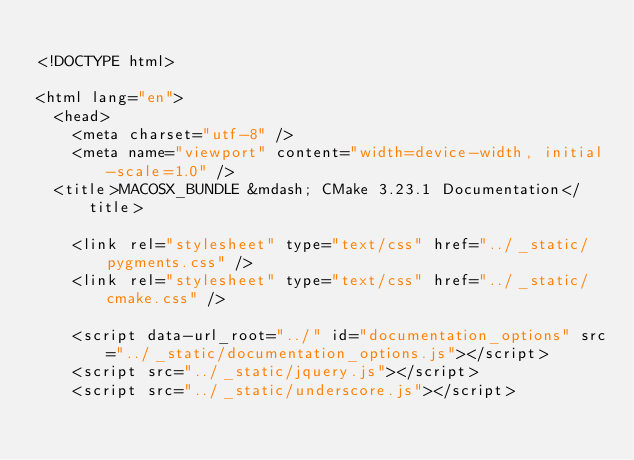<code> <loc_0><loc_0><loc_500><loc_500><_HTML_>
<!DOCTYPE html>

<html lang="en">
  <head>
    <meta charset="utf-8" />
    <meta name="viewport" content="width=device-width, initial-scale=1.0" />
  <title>MACOSX_BUNDLE &mdash; CMake 3.23.1 Documentation</title>

    <link rel="stylesheet" type="text/css" href="../_static/pygments.css" />
    <link rel="stylesheet" type="text/css" href="../_static/cmake.css" />
    
    <script data-url_root="../" id="documentation_options" src="../_static/documentation_options.js"></script>
    <script src="../_static/jquery.js"></script>
    <script src="../_static/underscore.js"></script></code> 